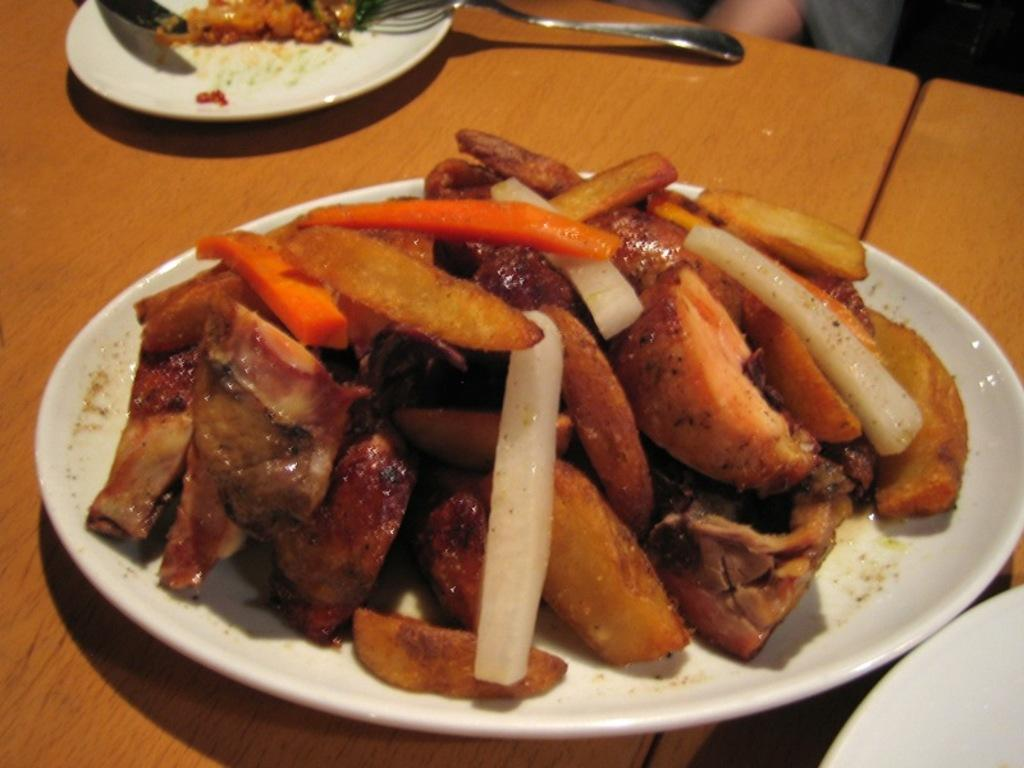What is on the plate in the image? The plate contains food. What type of food is on the plate? The food appears to be meat. Are there any other plates visible in the image? Yes, there is a small plate in the image. What is on the small plate? The small plate contains spoons. Is there a rat causing pain to the person holding the crook in the image? There is no person holding a crook or rat present in the image. 